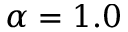Convert formula to latex. <formula><loc_0><loc_0><loc_500><loc_500>\alpha = 1 . 0</formula> 